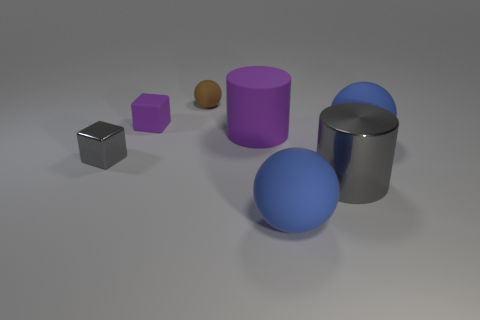Add 2 big gray shiny objects. How many objects exist? 9 Subtract all balls. How many objects are left? 4 Subtract all purple things. Subtract all tiny gray shiny cubes. How many objects are left? 4 Add 2 big blue rubber spheres. How many big blue rubber spheres are left? 4 Add 6 shiny objects. How many shiny objects exist? 8 Subtract 1 purple cylinders. How many objects are left? 6 